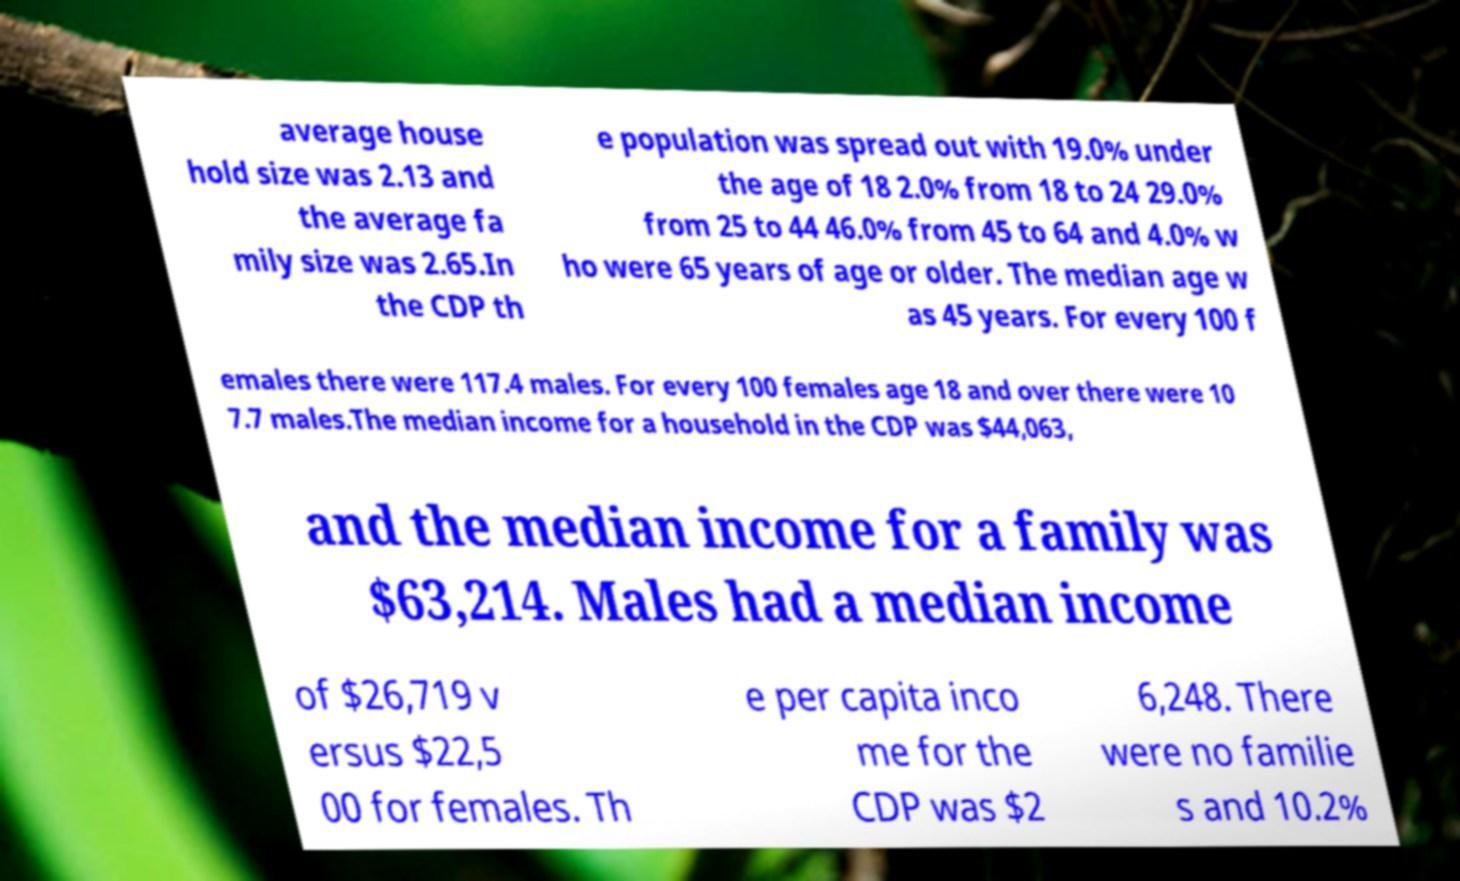Could you extract and type out the text from this image? average house hold size was 2.13 and the average fa mily size was 2.65.In the CDP th e population was spread out with 19.0% under the age of 18 2.0% from 18 to 24 29.0% from 25 to 44 46.0% from 45 to 64 and 4.0% w ho were 65 years of age or older. The median age w as 45 years. For every 100 f emales there were 117.4 males. For every 100 females age 18 and over there were 10 7.7 males.The median income for a household in the CDP was $44,063, and the median income for a family was $63,214. Males had a median income of $26,719 v ersus $22,5 00 for females. Th e per capita inco me for the CDP was $2 6,248. There were no familie s and 10.2% 